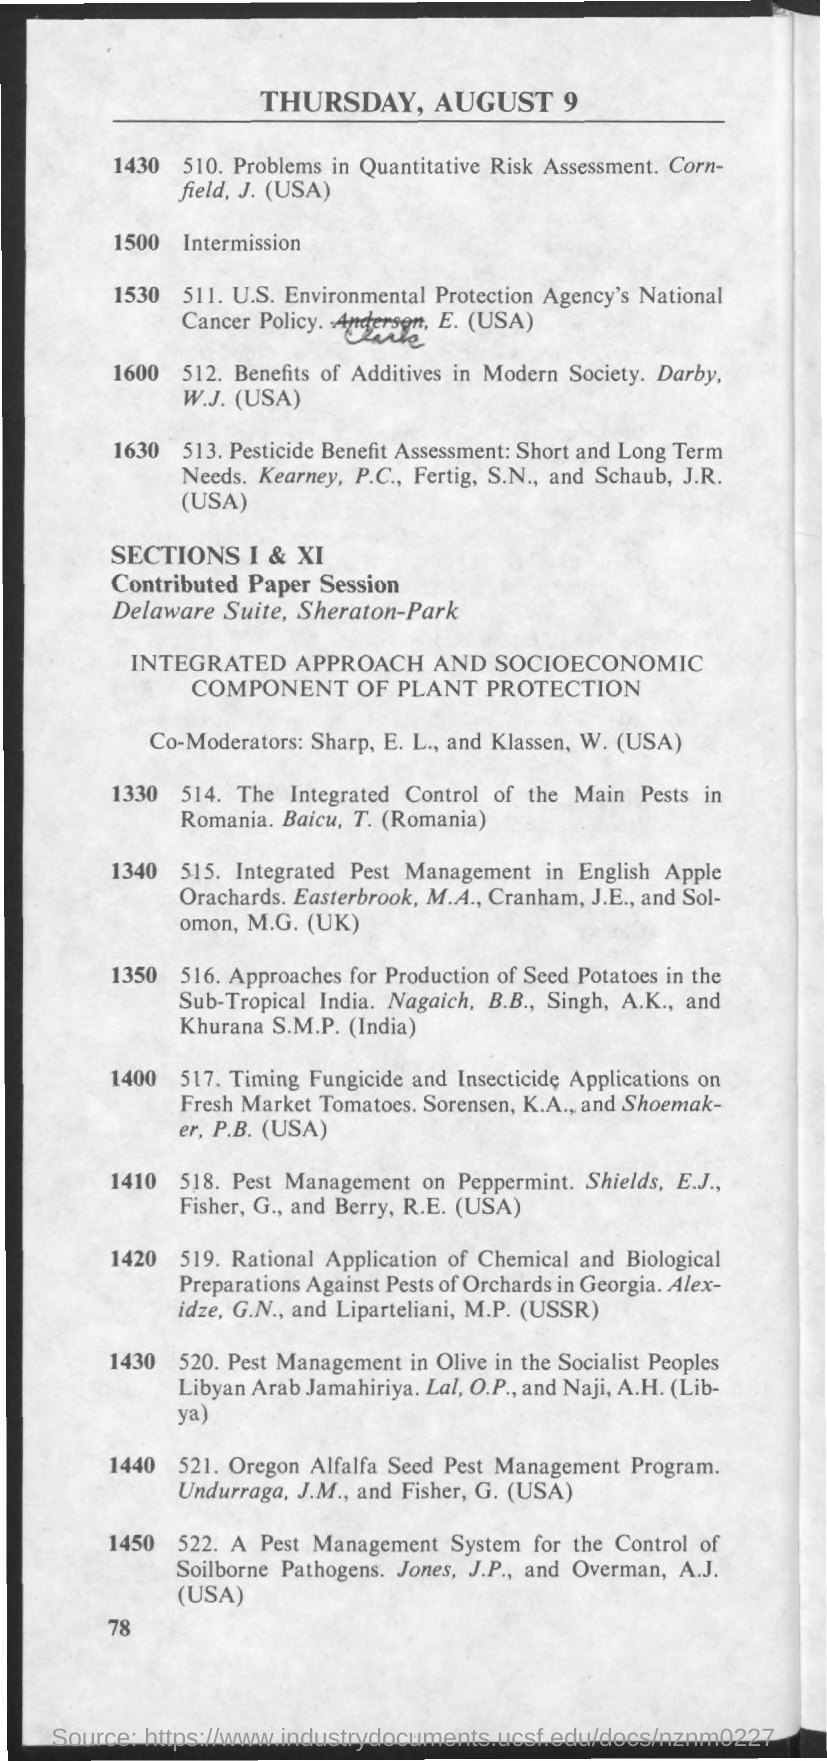Draw attention to some important aspects in this diagram. Klassen, from the United States of America, is from the country of the United States of America. Robert E. Berry is an American citizen. Dr. Surabhi Khurana is an Indian medical professional. 